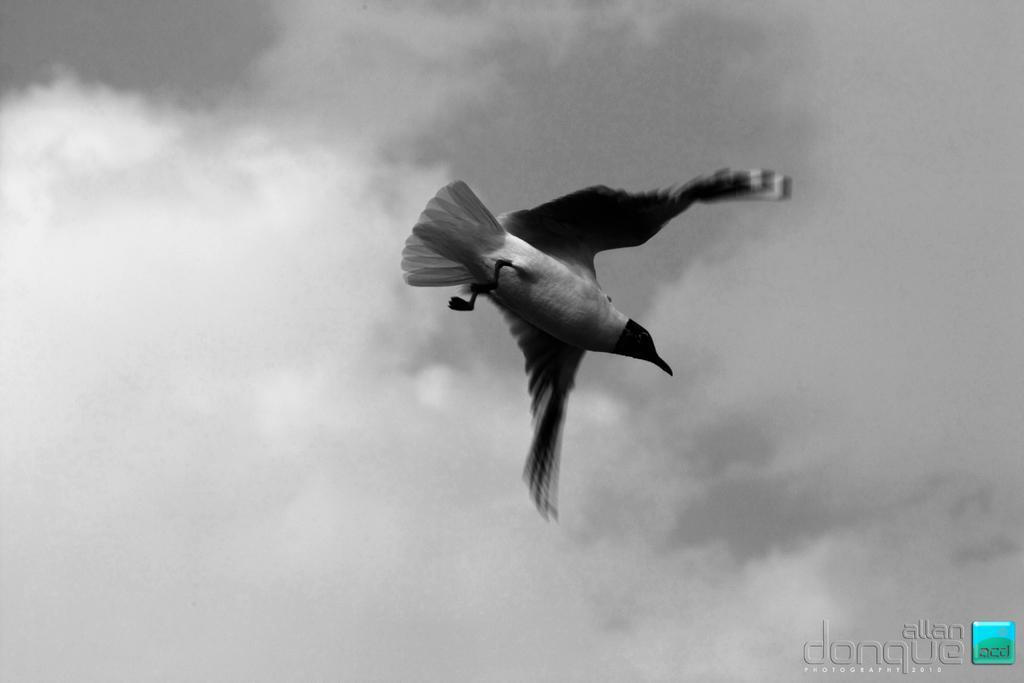Can you describe this image briefly? This is a black and white image where we can see a bird is flying in the air. In the background, we can see the sky with clouds and here we can see the watermark on the bottom right side of the image. 